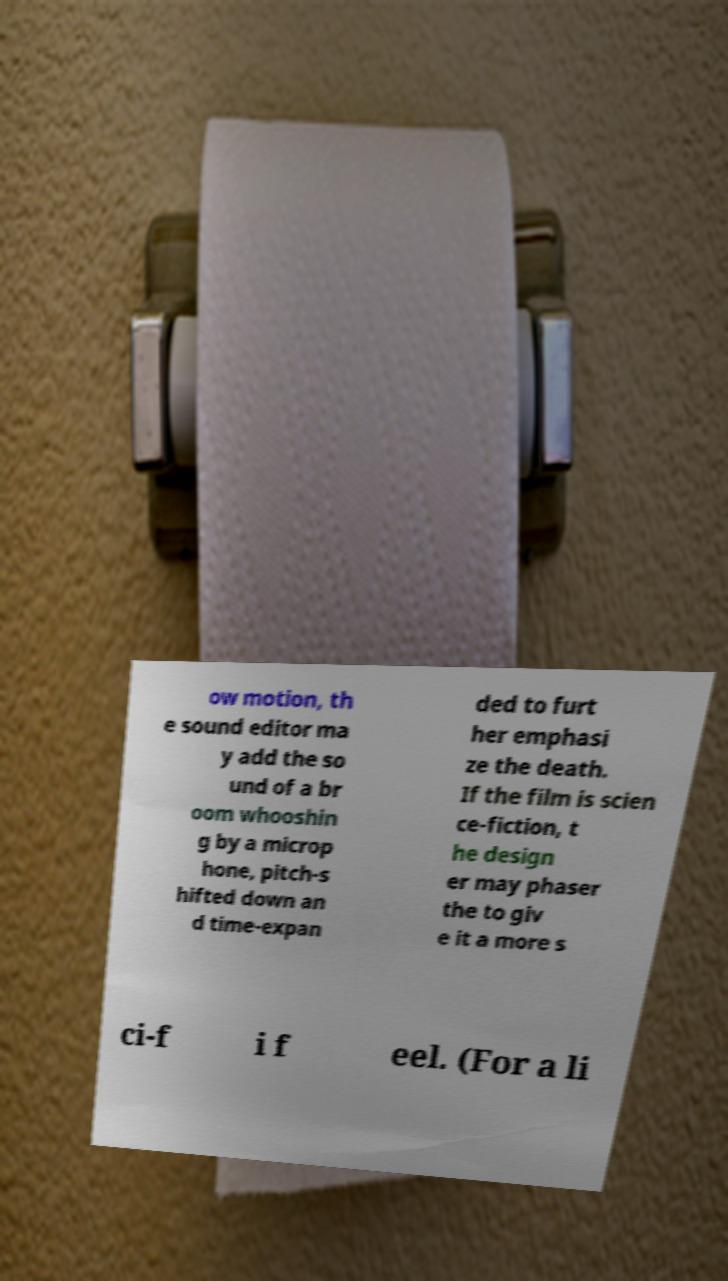Could you assist in decoding the text presented in this image and type it out clearly? ow motion, th e sound editor ma y add the so und of a br oom whooshin g by a microp hone, pitch-s hifted down an d time-expan ded to furt her emphasi ze the death. If the film is scien ce-fiction, t he design er may phaser the to giv e it a more s ci-f i f eel. (For a li 